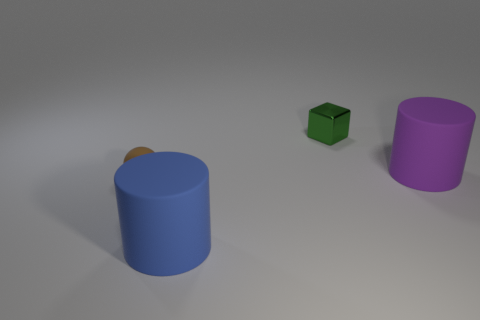Add 4 blue things. How many objects exist? 8 Subtract all spheres. How many objects are left? 3 Subtract 0 yellow cylinders. How many objects are left? 4 Subtract all green objects. Subtract all large blue rubber cylinders. How many objects are left? 2 Add 1 large things. How many large things are left? 3 Add 3 large red cubes. How many large red cubes exist? 3 